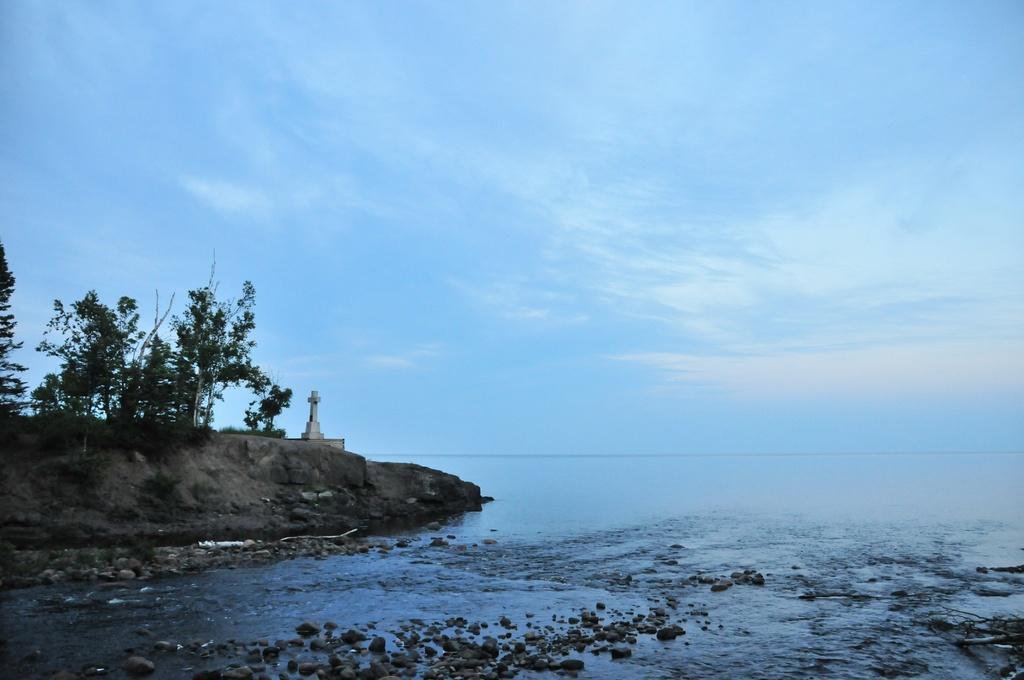Please provide a concise description of this image. At the bottom we can see stones and water and on the left there are trees and a cross symbol on the ground. In the background we can see water and clouds in the sky. 